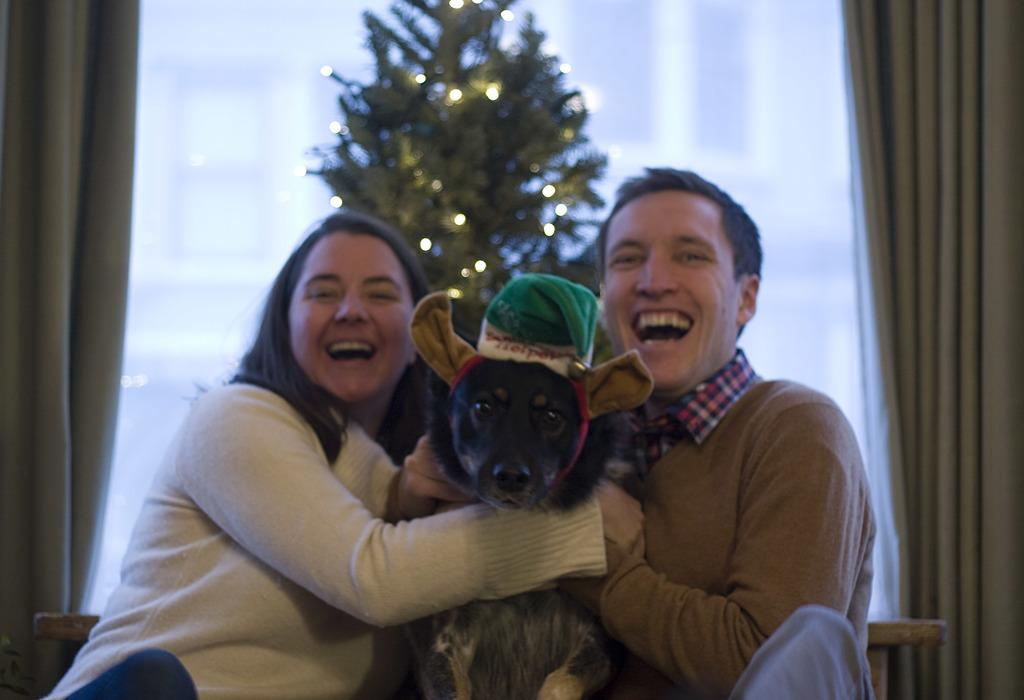How many people are sitting in the image? There are 2 people sitting in the image. What is between the two people? There is a black dog between them. What is unique about the dog's appearance? The dog is wearing a green cap. What can be seen in the background of the image? There is a Christmas tree and curtains in the background. What type of cork can be seen in the image? There is no cork present in the image. What season is depicted in the image? The presence of a Christmas tree suggests that the image might be set during the winter season, but the specific season cannot be definitively determined from the image alone. 